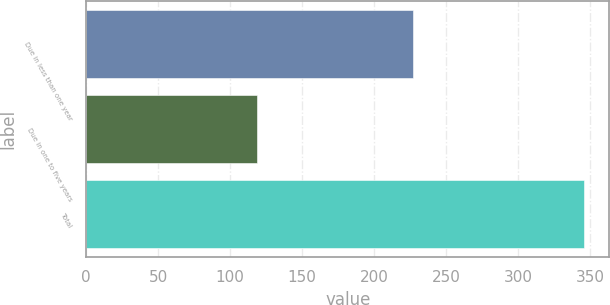Convert chart. <chart><loc_0><loc_0><loc_500><loc_500><bar_chart><fcel>Due in less than one year<fcel>Due in one to five years<fcel>Total<nl><fcel>227<fcel>119<fcel>346<nl></chart> 